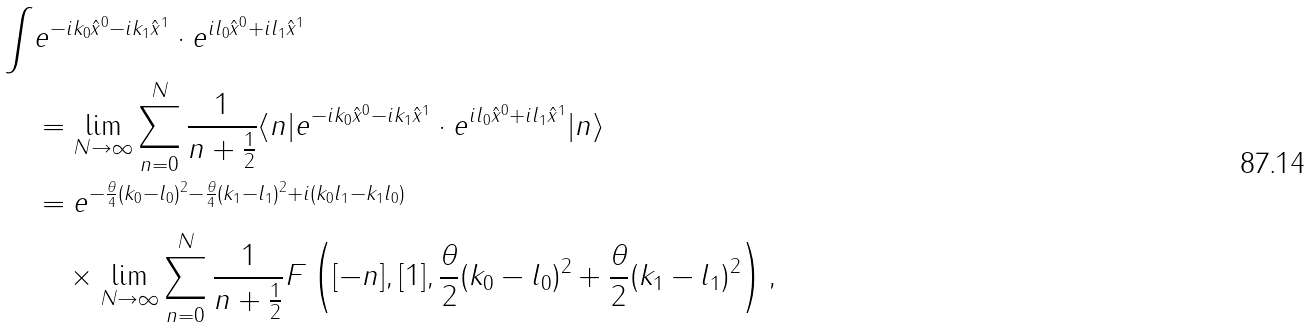Convert formula to latex. <formula><loc_0><loc_0><loc_500><loc_500>\int & e ^ { - i k _ { 0 } \hat { x } ^ { 0 } - i k _ { 1 } \hat { x } ^ { 1 } } \cdot e ^ { i l _ { 0 } \hat { x } ^ { 0 } + i l _ { 1 } \hat { x } ^ { 1 } } \\ & = \lim _ { N \to \infty } \sum _ { n = 0 } ^ { N } \frac { 1 } { n + \frac { 1 } { 2 } } \langle n | e ^ { - i k _ { 0 } \hat { x } ^ { 0 } - i k _ { 1 } \hat { x } ^ { 1 } } \cdot e ^ { i l _ { 0 } \hat { x } ^ { 0 } + i l _ { 1 } \hat { x } ^ { 1 } } | n \rangle \\ & = e ^ { - \frac { \theta } { 4 } ( k _ { 0 } - l _ { 0 } ) ^ { 2 } - \frac { \theta } { 4 } ( k _ { 1 } - l _ { 1 } ) ^ { 2 } + i ( k _ { 0 } l _ { 1 } - k _ { 1 } l _ { 0 } ) } \\ & \quad \times \lim _ { N \to \infty } \sum _ { n = 0 } ^ { N } \frac { 1 } { n + \frac { 1 } { 2 } } F \left ( [ - n ] , [ 1 ] , \frac { \theta } { 2 } ( k _ { 0 } - l _ { 0 } ) ^ { 2 } + \frac { \theta } { 2 } ( k _ { 1 } - l _ { 1 } ) ^ { 2 } \right ) ,</formula> 